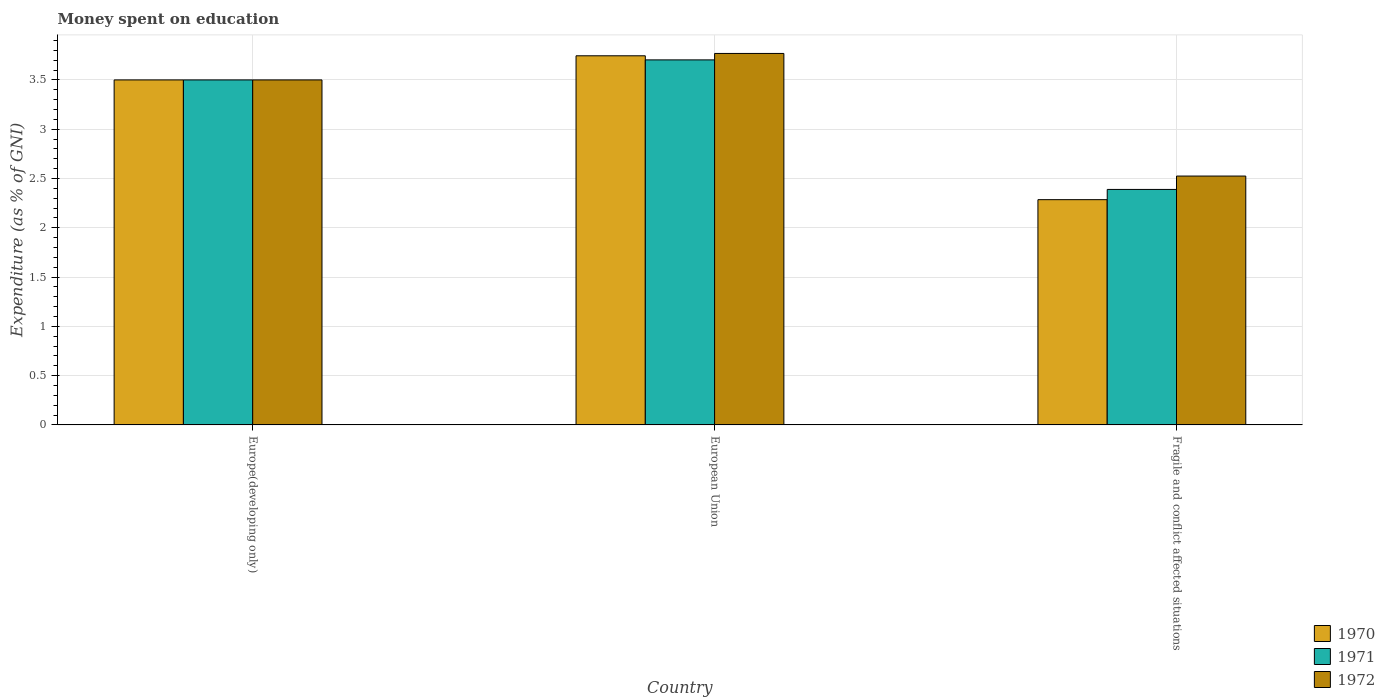How many bars are there on the 1st tick from the right?
Your answer should be very brief. 3. What is the label of the 3rd group of bars from the left?
Your response must be concise. Fragile and conflict affected situations. What is the amount of money spent on education in 1971 in European Union?
Make the answer very short. 3.7. Across all countries, what is the maximum amount of money spent on education in 1970?
Offer a very short reply. 3.74. Across all countries, what is the minimum amount of money spent on education in 1970?
Offer a very short reply. 2.29. In which country was the amount of money spent on education in 1971 maximum?
Offer a terse response. European Union. In which country was the amount of money spent on education in 1970 minimum?
Your response must be concise. Fragile and conflict affected situations. What is the total amount of money spent on education in 1971 in the graph?
Keep it short and to the point. 9.59. What is the difference between the amount of money spent on education in 1970 in Europe(developing only) and that in European Union?
Offer a terse response. -0.24. What is the difference between the amount of money spent on education in 1970 in Europe(developing only) and the amount of money spent on education in 1971 in European Union?
Ensure brevity in your answer.  -0.2. What is the average amount of money spent on education in 1971 per country?
Ensure brevity in your answer.  3.2. What is the difference between the amount of money spent on education of/in 1970 and amount of money spent on education of/in 1971 in Fragile and conflict affected situations?
Provide a short and direct response. -0.1. In how many countries, is the amount of money spent on education in 1972 greater than 0.5 %?
Offer a terse response. 3. What is the ratio of the amount of money spent on education in 1970 in European Union to that in Fragile and conflict affected situations?
Your answer should be compact. 1.64. Is the difference between the amount of money spent on education in 1970 in Europe(developing only) and European Union greater than the difference between the amount of money spent on education in 1971 in Europe(developing only) and European Union?
Offer a terse response. No. What is the difference between the highest and the second highest amount of money spent on education in 1972?
Offer a terse response. 0.98. What is the difference between the highest and the lowest amount of money spent on education in 1970?
Your answer should be compact. 1.46. How many bars are there?
Make the answer very short. 9. Are all the bars in the graph horizontal?
Offer a very short reply. No. What is the difference between two consecutive major ticks on the Y-axis?
Your response must be concise. 0.5. Are the values on the major ticks of Y-axis written in scientific E-notation?
Your answer should be very brief. No. Does the graph contain any zero values?
Provide a succinct answer. No. How many legend labels are there?
Offer a terse response. 3. What is the title of the graph?
Your response must be concise. Money spent on education. Does "1988" appear as one of the legend labels in the graph?
Offer a terse response. No. What is the label or title of the Y-axis?
Your answer should be compact. Expenditure (as % of GNI). What is the Expenditure (as % of GNI) in 1971 in Europe(developing only)?
Provide a succinct answer. 3.5. What is the Expenditure (as % of GNI) in 1970 in European Union?
Your answer should be compact. 3.74. What is the Expenditure (as % of GNI) in 1971 in European Union?
Ensure brevity in your answer.  3.7. What is the Expenditure (as % of GNI) of 1972 in European Union?
Your answer should be very brief. 3.77. What is the Expenditure (as % of GNI) in 1970 in Fragile and conflict affected situations?
Provide a short and direct response. 2.29. What is the Expenditure (as % of GNI) in 1971 in Fragile and conflict affected situations?
Offer a terse response. 2.39. What is the Expenditure (as % of GNI) in 1972 in Fragile and conflict affected situations?
Your answer should be very brief. 2.52. Across all countries, what is the maximum Expenditure (as % of GNI) in 1970?
Your response must be concise. 3.74. Across all countries, what is the maximum Expenditure (as % of GNI) in 1971?
Provide a succinct answer. 3.7. Across all countries, what is the maximum Expenditure (as % of GNI) of 1972?
Provide a short and direct response. 3.77. Across all countries, what is the minimum Expenditure (as % of GNI) of 1970?
Provide a short and direct response. 2.29. Across all countries, what is the minimum Expenditure (as % of GNI) of 1971?
Keep it short and to the point. 2.39. Across all countries, what is the minimum Expenditure (as % of GNI) in 1972?
Offer a terse response. 2.52. What is the total Expenditure (as % of GNI) in 1970 in the graph?
Your answer should be very brief. 9.53. What is the total Expenditure (as % of GNI) of 1971 in the graph?
Your response must be concise. 9.59. What is the total Expenditure (as % of GNI) in 1972 in the graph?
Offer a terse response. 9.79. What is the difference between the Expenditure (as % of GNI) of 1970 in Europe(developing only) and that in European Union?
Ensure brevity in your answer.  -0.24. What is the difference between the Expenditure (as % of GNI) of 1971 in Europe(developing only) and that in European Union?
Ensure brevity in your answer.  -0.2. What is the difference between the Expenditure (as % of GNI) of 1972 in Europe(developing only) and that in European Union?
Give a very brief answer. -0.27. What is the difference between the Expenditure (as % of GNI) of 1970 in Europe(developing only) and that in Fragile and conflict affected situations?
Give a very brief answer. 1.21. What is the difference between the Expenditure (as % of GNI) in 1971 in Europe(developing only) and that in Fragile and conflict affected situations?
Provide a short and direct response. 1.11. What is the difference between the Expenditure (as % of GNI) in 1972 in Europe(developing only) and that in Fragile and conflict affected situations?
Your response must be concise. 0.98. What is the difference between the Expenditure (as % of GNI) of 1970 in European Union and that in Fragile and conflict affected situations?
Your answer should be compact. 1.46. What is the difference between the Expenditure (as % of GNI) of 1971 in European Union and that in Fragile and conflict affected situations?
Give a very brief answer. 1.31. What is the difference between the Expenditure (as % of GNI) in 1972 in European Union and that in Fragile and conflict affected situations?
Offer a terse response. 1.24. What is the difference between the Expenditure (as % of GNI) in 1970 in Europe(developing only) and the Expenditure (as % of GNI) in 1971 in European Union?
Your response must be concise. -0.2. What is the difference between the Expenditure (as % of GNI) in 1970 in Europe(developing only) and the Expenditure (as % of GNI) in 1972 in European Union?
Ensure brevity in your answer.  -0.27. What is the difference between the Expenditure (as % of GNI) of 1971 in Europe(developing only) and the Expenditure (as % of GNI) of 1972 in European Union?
Ensure brevity in your answer.  -0.27. What is the difference between the Expenditure (as % of GNI) of 1970 in Europe(developing only) and the Expenditure (as % of GNI) of 1971 in Fragile and conflict affected situations?
Give a very brief answer. 1.11. What is the difference between the Expenditure (as % of GNI) of 1970 in Europe(developing only) and the Expenditure (as % of GNI) of 1972 in Fragile and conflict affected situations?
Your answer should be very brief. 0.98. What is the difference between the Expenditure (as % of GNI) of 1971 in Europe(developing only) and the Expenditure (as % of GNI) of 1972 in Fragile and conflict affected situations?
Offer a very short reply. 0.98. What is the difference between the Expenditure (as % of GNI) in 1970 in European Union and the Expenditure (as % of GNI) in 1971 in Fragile and conflict affected situations?
Provide a short and direct response. 1.36. What is the difference between the Expenditure (as % of GNI) in 1970 in European Union and the Expenditure (as % of GNI) in 1972 in Fragile and conflict affected situations?
Your answer should be very brief. 1.22. What is the difference between the Expenditure (as % of GNI) in 1971 in European Union and the Expenditure (as % of GNI) in 1972 in Fragile and conflict affected situations?
Your answer should be compact. 1.18. What is the average Expenditure (as % of GNI) of 1970 per country?
Provide a succinct answer. 3.18. What is the average Expenditure (as % of GNI) in 1971 per country?
Your answer should be compact. 3.2. What is the average Expenditure (as % of GNI) in 1972 per country?
Your response must be concise. 3.26. What is the difference between the Expenditure (as % of GNI) in 1970 and Expenditure (as % of GNI) in 1972 in Europe(developing only)?
Your answer should be very brief. 0. What is the difference between the Expenditure (as % of GNI) in 1971 and Expenditure (as % of GNI) in 1972 in Europe(developing only)?
Your answer should be very brief. 0. What is the difference between the Expenditure (as % of GNI) of 1970 and Expenditure (as % of GNI) of 1971 in European Union?
Offer a very short reply. 0.04. What is the difference between the Expenditure (as % of GNI) in 1970 and Expenditure (as % of GNI) in 1972 in European Union?
Provide a succinct answer. -0.02. What is the difference between the Expenditure (as % of GNI) of 1971 and Expenditure (as % of GNI) of 1972 in European Union?
Provide a succinct answer. -0.07. What is the difference between the Expenditure (as % of GNI) of 1970 and Expenditure (as % of GNI) of 1971 in Fragile and conflict affected situations?
Give a very brief answer. -0.1. What is the difference between the Expenditure (as % of GNI) in 1970 and Expenditure (as % of GNI) in 1972 in Fragile and conflict affected situations?
Provide a short and direct response. -0.24. What is the difference between the Expenditure (as % of GNI) in 1971 and Expenditure (as % of GNI) in 1972 in Fragile and conflict affected situations?
Offer a very short reply. -0.14. What is the ratio of the Expenditure (as % of GNI) in 1970 in Europe(developing only) to that in European Union?
Your answer should be very brief. 0.93. What is the ratio of the Expenditure (as % of GNI) of 1971 in Europe(developing only) to that in European Union?
Offer a very short reply. 0.95. What is the ratio of the Expenditure (as % of GNI) in 1972 in Europe(developing only) to that in European Union?
Provide a succinct answer. 0.93. What is the ratio of the Expenditure (as % of GNI) in 1970 in Europe(developing only) to that in Fragile and conflict affected situations?
Offer a terse response. 1.53. What is the ratio of the Expenditure (as % of GNI) of 1971 in Europe(developing only) to that in Fragile and conflict affected situations?
Give a very brief answer. 1.47. What is the ratio of the Expenditure (as % of GNI) of 1972 in Europe(developing only) to that in Fragile and conflict affected situations?
Offer a very short reply. 1.39. What is the ratio of the Expenditure (as % of GNI) in 1970 in European Union to that in Fragile and conflict affected situations?
Make the answer very short. 1.64. What is the ratio of the Expenditure (as % of GNI) in 1971 in European Union to that in Fragile and conflict affected situations?
Offer a very short reply. 1.55. What is the ratio of the Expenditure (as % of GNI) in 1972 in European Union to that in Fragile and conflict affected situations?
Your response must be concise. 1.49. What is the difference between the highest and the second highest Expenditure (as % of GNI) of 1970?
Your response must be concise. 0.24. What is the difference between the highest and the second highest Expenditure (as % of GNI) of 1971?
Your answer should be very brief. 0.2. What is the difference between the highest and the second highest Expenditure (as % of GNI) in 1972?
Keep it short and to the point. 0.27. What is the difference between the highest and the lowest Expenditure (as % of GNI) of 1970?
Keep it short and to the point. 1.46. What is the difference between the highest and the lowest Expenditure (as % of GNI) in 1971?
Keep it short and to the point. 1.31. What is the difference between the highest and the lowest Expenditure (as % of GNI) in 1972?
Ensure brevity in your answer.  1.24. 